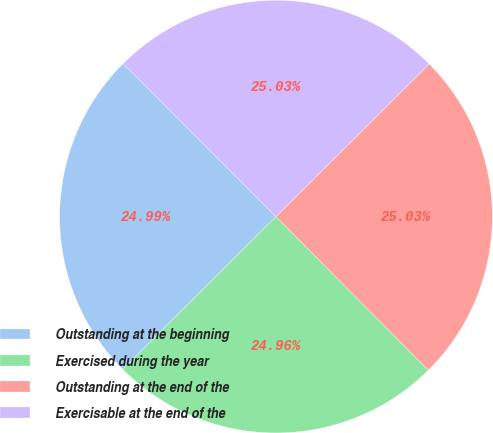<chart> <loc_0><loc_0><loc_500><loc_500><pie_chart><fcel>Outstanding at the beginning<fcel>Exercised during the year<fcel>Outstanding at the end of the<fcel>Exercisable at the end of the<nl><fcel>24.99%<fcel>24.96%<fcel>25.03%<fcel>25.03%<nl></chart> 